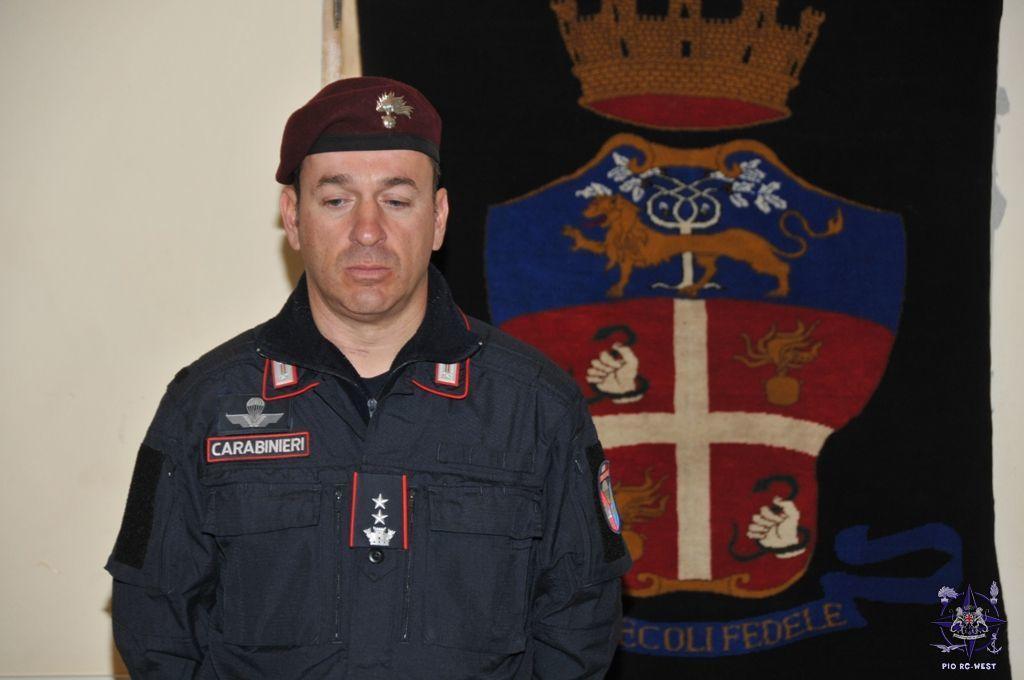In one or two sentences, can you explain what this image depicts? In the image, we can see a man is standing. He is wearing blue color hoodie and cap over his head. Behind the person there is a wall and a poster. 